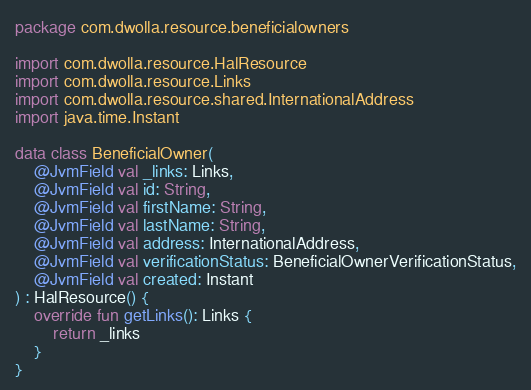Convert code to text. <code><loc_0><loc_0><loc_500><loc_500><_Kotlin_>package com.dwolla.resource.beneficialowners

import com.dwolla.resource.HalResource
import com.dwolla.resource.Links
import com.dwolla.resource.shared.InternationalAddress
import java.time.Instant

data class BeneficialOwner(
    @JvmField val _links: Links,
    @JvmField val id: String,
    @JvmField val firstName: String,
    @JvmField val lastName: String,
    @JvmField val address: InternationalAddress,
    @JvmField val verificationStatus: BeneficialOwnerVerificationStatus,
    @JvmField val created: Instant
) : HalResource() {
    override fun getLinks(): Links {
        return _links
    }
}
</code> 